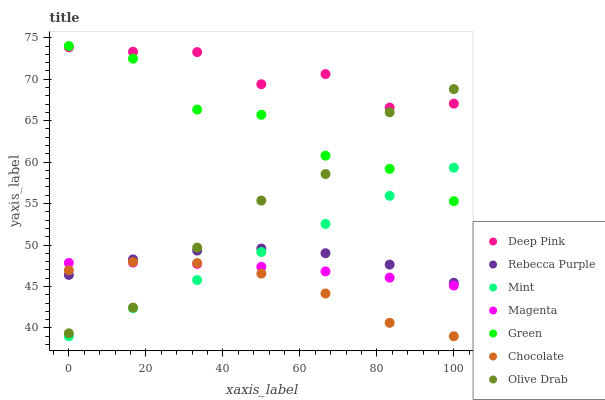Does Chocolate have the minimum area under the curve?
Answer yes or no. Yes. Does Deep Pink have the maximum area under the curve?
Answer yes or no. Yes. Does Green have the minimum area under the curve?
Answer yes or no. No. Does Green have the maximum area under the curve?
Answer yes or no. No. Is Mint the smoothest?
Answer yes or no. Yes. Is Green the roughest?
Answer yes or no. Yes. Is Chocolate the smoothest?
Answer yes or no. No. Is Chocolate the roughest?
Answer yes or no. No. Does Chocolate have the lowest value?
Answer yes or no. Yes. Does Green have the lowest value?
Answer yes or no. No. Does Green have the highest value?
Answer yes or no. Yes. Does Chocolate have the highest value?
Answer yes or no. No. Is Mint less than Deep Pink?
Answer yes or no. Yes. Is Green greater than Rebecca Purple?
Answer yes or no. Yes. Does Magenta intersect Olive Drab?
Answer yes or no. Yes. Is Magenta less than Olive Drab?
Answer yes or no. No. Is Magenta greater than Olive Drab?
Answer yes or no. No. Does Mint intersect Deep Pink?
Answer yes or no. No. 